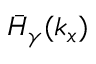Convert formula to latex. <formula><loc_0><loc_0><loc_500><loc_500>\bar { H } _ { \gamma } ( k _ { x } )</formula> 